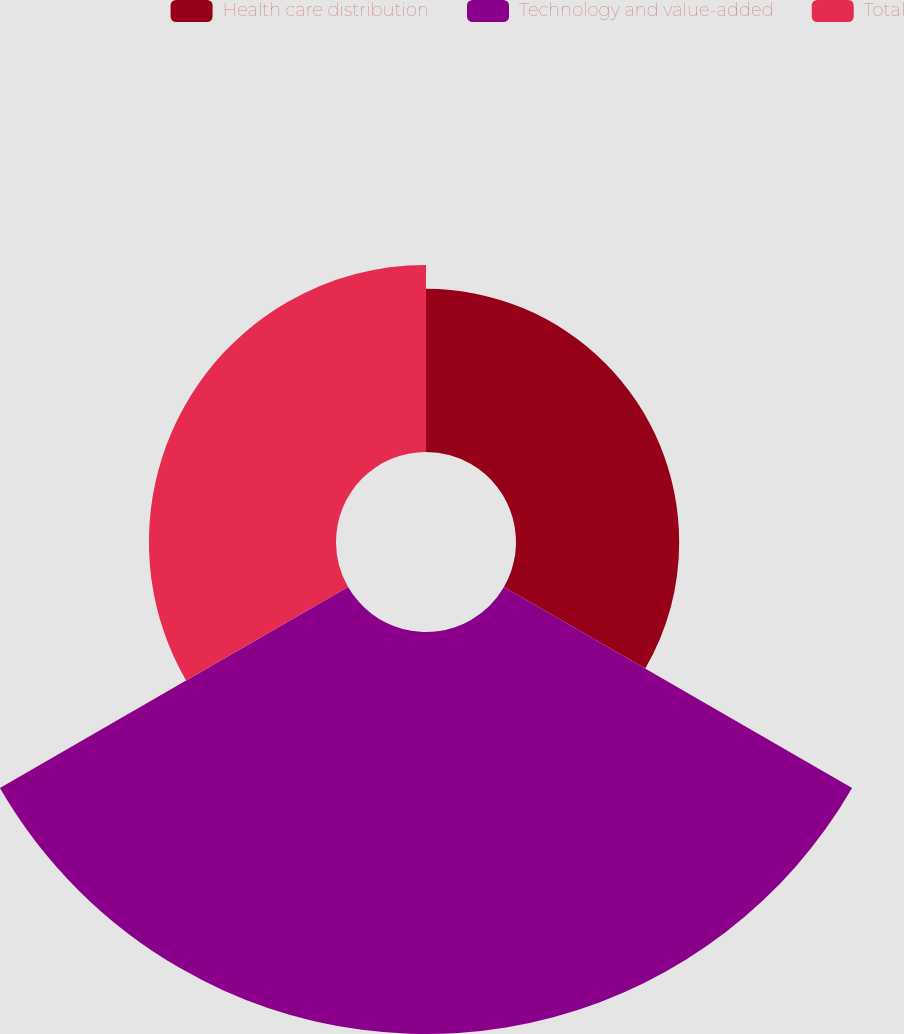Convert chart to OTSL. <chart><loc_0><loc_0><loc_500><loc_500><pie_chart><fcel>Health care distribution<fcel>Technology and value-added<fcel>Total<nl><fcel>21.69%<fcel>53.44%<fcel>24.87%<nl></chart> 